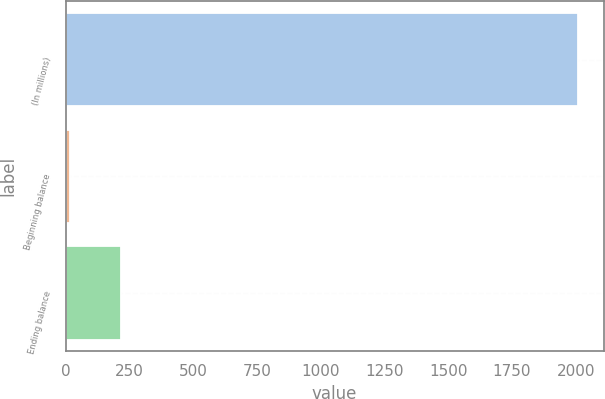Convert chart. <chart><loc_0><loc_0><loc_500><loc_500><bar_chart><fcel>(In millions)<fcel>Beginning balance<fcel>Ending balance<nl><fcel>2009<fcel>18<fcel>217.1<nl></chart> 